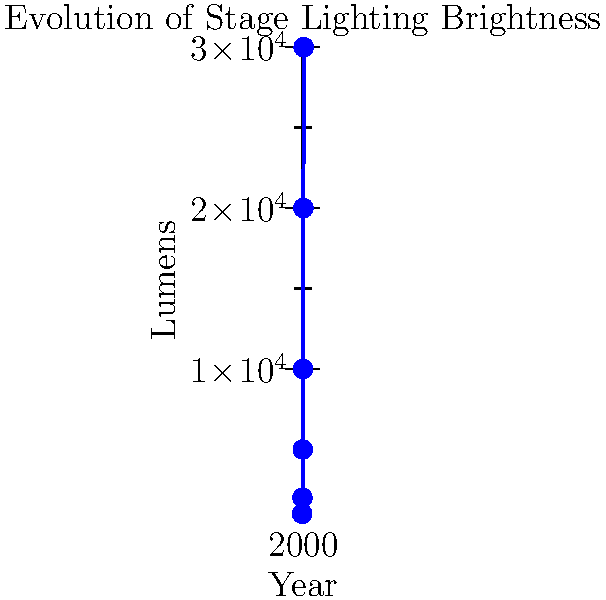Based on the graph showing the evolution of stage lighting brightness at the Virginia Theatre, approximately how many times brighter were the lights in 2020 compared to 1920? To determine how many times brighter the lights were in 2020 compared to 1920, we need to follow these steps:

1. Identify the brightness (in lumens) for 1920:
   From the graph, we can see that in 1920, the brightness was approximately 1,000 lumens.

2. Identify the brightness (in lumens) for 2020:
   From the graph, we can see that in 2020, the brightness was approximately 30,000 lumens.

3. Calculate the ratio of brightness in 2020 to 1920:
   $\text{Ratio} = \frac{\text{Brightness in 2020}}{\text{Brightness in 1920}}$
   $\text{Ratio} = \frac{30,000 \text{ lumens}}{1,000 \text{ lumens}} = 30$

Therefore, the lights in 2020 were approximately 30 times brighter than in 1920.
Answer: 30 times brighter 